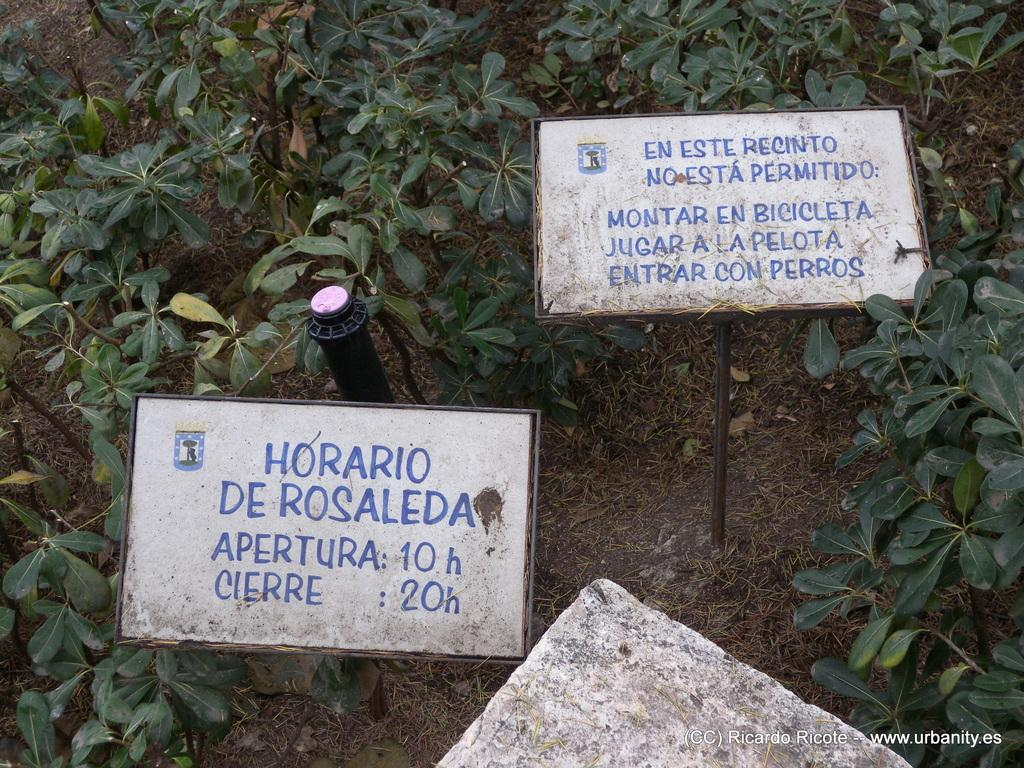What type of living organisms can be seen in the image? Plants and grass are visible in the image. What type of advertising or signage can be seen in the image? There are hoardings in the image. What type of natural ground cover is present in the image? Grass and dry leaves are present in the image. What type of material is visible in the image that supports plant growth? Soil is visible in the image. What device is present in the image that is used for watering plants? There is a sprinkler in the center of the image. Can you tell me how many flies are depicted on the hoardings in the image? There are no flies depicted on the hoardings or anywhere else in the image. Is there a woman in the image having trouble with the sprinkler? There is no woman present in the image, and the sprinkler appears to be functioning normally. 